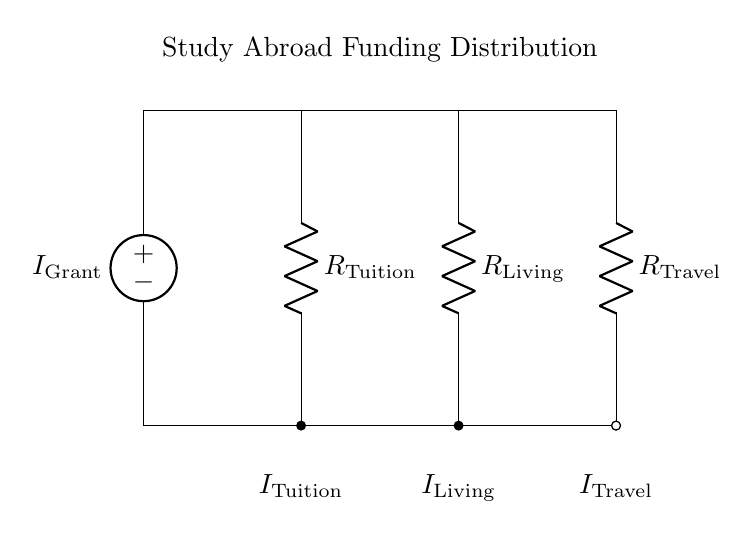What is the current source in this circuit? The current source in this circuit is represented by the symbol I Grant located at the top left of the diagram. It is the only current entering the circuit, indicating the total grant money available for distribution.
Answer: I Grant How many resistors are present in the circuit? The circuit diagram includes three resistors: R Tuition, R Living, and R Travel. Each resistor represents the allocation of funds to different aspects of study abroad expenses.
Answer: Three Which component represents tuition expenses? The component representing tuition expenses is labeled R Tuition, located at the first branch of the circuit after the current source.
Answer: R Tuition How is the total current distributed in the branches? The total current I Grant is divided among the three resistors according to their resistances. This division means that the currents I Tuition, I Living, and I Travel are proportional to the values of R Tuition, R Living, and R Travel, satisfying the current divider rule.
Answer: Proportional to resistances What can you say about the relationship between the resistors in terms of current flow? The relationship is defined by the current divider principle, which states that the current flowing through each resistor is inversely proportional to its resistance. In other words, a lower resistance will draw more current compared to a higher resistance in the circuit.
Answer: Inversely proportional What does the notation I Living represent? The notation I Living signifies the current flowing through the resistor R Living, which corresponds to the portion of the grant allocated for living expenses while studying abroad.
Answer: Current for living expenses 